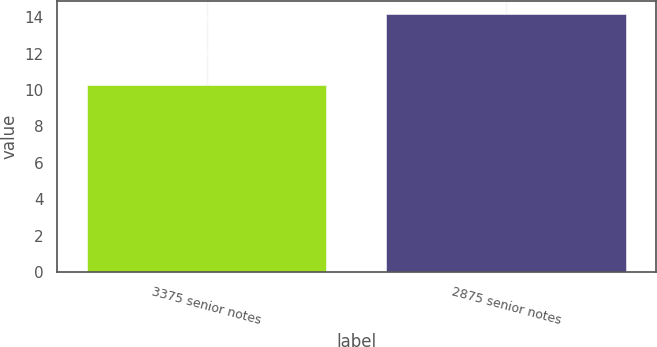<chart> <loc_0><loc_0><loc_500><loc_500><bar_chart><fcel>3375 senior notes<fcel>2875 senior notes<nl><fcel>10.26<fcel>14.18<nl></chart> 